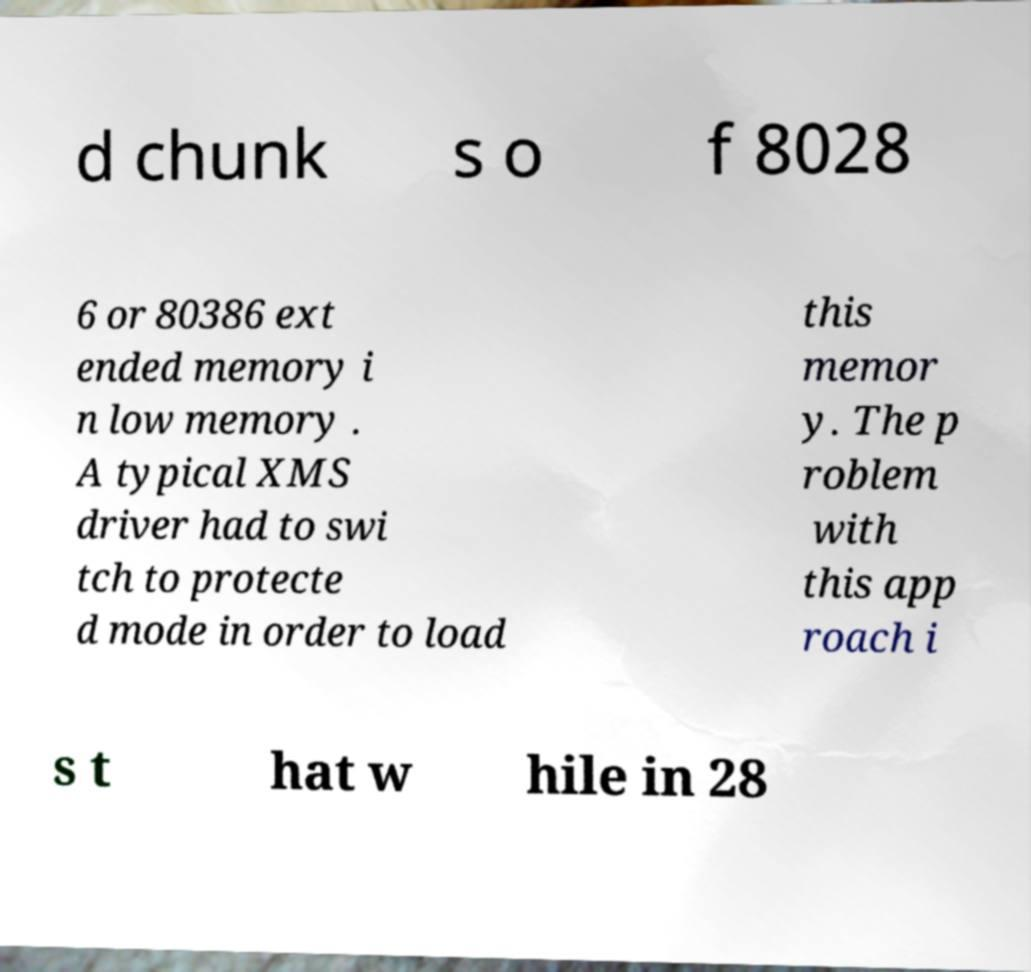Can you read and provide the text displayed in the image?This photo seems to have some interesting text. Can you extract and type it out for me? d chunk s o f 8028 6 or 80386 ext ended memory i n low memory . A typical XMS driver had to swi tch to protecte d mode in order to load this memor y. The p roblem with this app roach i s t hat w hile in 28 